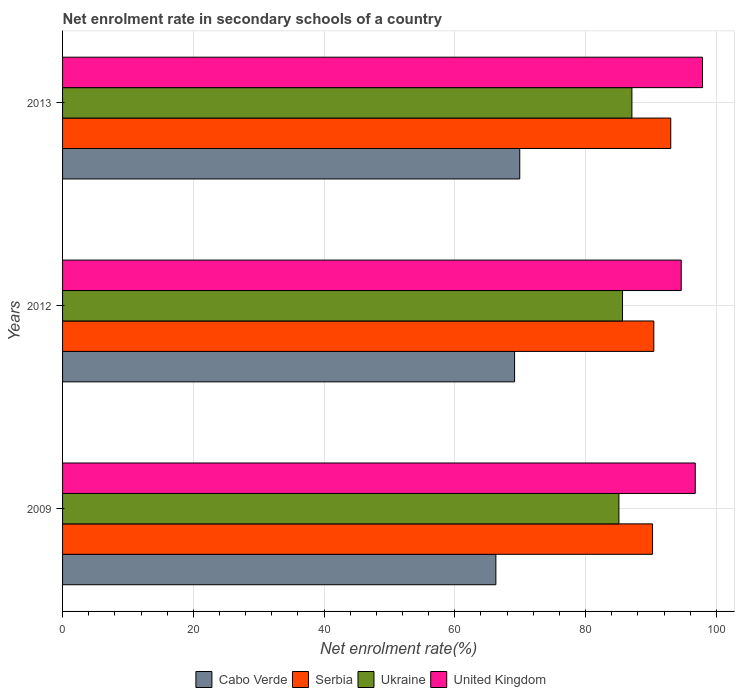How many groups of bars are there?
Your answer should be very brief. 3. What is the net enrolment rate in secondary schools in United Kingdom in 2012?
Provide a short and direct response. 94.63. Across all years, what is the maximum net enrolment rate in secondary schools in Ukraine?
Your answer should be very brief. 87.09. Across all years, what is the minimum net enrolment rate in secondary schools in United Kingdom?
Your answer should be compact. 94.63. In which year was the net enrolment rate in secondary schools in United Kingdom maximum?
Your answer should be very brief. 2013. In which year was the net enrolment rate in secondary schools in Serbia minimum?
Your answer should be very brief. 2009. What is the total net enrolment rate in secondary schools in United Kingdom in the graph?
Give a very brief answer. 289.29. What is the difference between the net enrolment rate in secondary schools in Ukraine in 2009 and that in 2012?
Your answer should be very brief. -0.55. What is the difference between the net enrolment rate in secondary schools in Serbia in 2009 and the net enrolment rate in secondary schools in United Kingdom in 2012?
Keep it short and to the point. -4.39. What is the average net enrolment rate in secondary schools in Cabo Verde per year?
Your answer should be very brief. 68.45. In the year 2009, what is the difference between the net enrolment rate in secondary schools in Serbia and net enrolment rate in secondary schools in United Kingdom?
Make the answer very short. -6.54. What is the ratio of the net enrolment rate in secondary schools in Cabo Verde in 2009 to that in 2012?
Make the answer very short. 0.96. What is the difference between the highest and the second highest net enrolment rate in secondary schools in United Kingdom?
Give a very brief answer. 1.11. What is the difference between the highest and the lowest net enrolment rate in secondary schools in United Kingdom?
Offer a terse response. 3.25. Is it the case that in every year, the sum of the net enrolment rate in secondary schools in Ukraine and net enrolment rate in secondary schools in Cabo Verde is greater than the sum of net enrolment rate in secondary schools in United Kingdom and net enrolment rate in secondary schools in Serbia?
Your answer should be compact. No. What does the 1st bar from the top in 2013 represents?
Offer a very short reply. United Kingdom. What does the 4th bar from the bottom in 2009 represents?
Make the answer very short. United Kingdom. Is it the case that in every year, the sum of the net enrolment rate in secondary schools in United Kingdom and net enrolment rate in secondary schools in Serbia is greater than the net enrolment rate in secondary schools in Cabo Verde?
Offer a terse response. Yes. How many years are there in the graph?
Your answer should be compact. 3. Are the values on the major ticks of X-axis written in scientific E-notation?
Make the answer very short. No. Does the graph contain grids?
Make the answer very short. Yes. Where does the legend appear in the graph?
Offer a terse response. Bottom center. What is the title of the graph?
Your answer should be very brief. Net enrolment rate in secondary schools of a country. Does "Middle East & North Africa (all income levels)" appear as one of the legend labels in the graph?
Ensure brevity in your answer.  No. What is the label or title of the X-axis?
Ensure brevity in your answer.  Net enrolment rate(%). What is the Net enrolment rate(%) of Cabo Verde in 2009?
Your answer should be compact. 66.28. What is the Net enrolment rate(%) of Serbia in 2009?
Your answer should be very brief. 90.24. What is the Net enrolment rate(%) in Ukraine in 2009?
Provide a short and direct response. 85.1. What is the Net enrolment rate(%) of United Kingdom in 2009?
Your answer should be compact. 96.78. What is the Net enrolment rate(%) in Cabo Verde in 2012?
Offer a terse response. 69.14. What is the Net enrolment rate(%) of Serbia in 2012?
Keep it short and to the point. 90.44. What is the Net enrolment rate(%) of Ukraine in 2012?
Provide a short and direct response. 85.65. What is the Net enrolment rate(%) of United Kingdom in 2012?
Give a very brief answer. 94.63. What is the Net enrolment rate(%) in Cabo Verde in 2013?
Give a very brief answer. 69.93. What is the Net enrolment rate(%) in Serbia in 2013?
Your answer should be compact. 93.03. What is the Net enrolment rate(%) of Ukraine in 2013?
Offer a very short reply. 87.09. What is the Net enrolment rate(%) of United Kingdom in 2013?
Make the answer very short. 97.88. Across all years, what is the maximum Net enrolment rate(%) of Cabo Verde?
Offer a terse response. 69.93. Across all years, what is the maximum Net enrolment rate(%) of Serbia?
Give a very brief answer. 93.03. Across all years, what is the maximum Net enrolment rate(%) of Ukraine?
Offer a very short reply. 87.09. Across all years, what is the maximum Net enrolment rate(%) of United Kingdom?
Your response must be concise. 97.88. Across all years, what is the minimum Net enrolment rate(%) in Cabo Verde?
Make the answer very short. 66.28. Across all years, what is the minimum Net enrolment rate(%) of Serbia?
Your response must be concise. 90.24. Across all years, what is the minimum Net enrolment rate(%) of Ukraine?
Offer a terse response. 85.1. Across all years, what is the minimum Net enrolment rate(%) in United Kingdom?
Your response must be concise. 94.63. What is the total Net enrolment rate(%) of Cabo Verde in the graph?
Ensure brevity in your answer.  205.35. What is the total Net enrolment rate(%) of Serbia in the graph?
Make the answer very short. 273.71. What is the total Net enrolment rate(%) of Ukraine in the graph?
Offer a very short reply. 257.84. What is the total Net enrolment rate(%) of United Kingdom in the graph?
Give a very brief answer. 289.29. What is the difference between the Net enrolment rate(%) in Cabo Verde in 2009 and that in 2012?
Your answer should be very brief. -2.86. What is the difference between the Net enrolment rate(%) of Serbia in 2009 and that in 2012?
Provide a succinct answer. -0.2. What is the difference between the Net enrolment rate(%) in Ukraine in 2009 and that in 2012?
Make the answer very short. -0.55. What is the difference between the Net enrolment rate(%) in United Kingdom in 2009 and that in 2012?
Offer a very short reply. 2.14. What is the difference between the Net enrolment rate(%) in Cabo Verde in 2009 and that in 2013?
Your answer should be very brief. -3.65. What is the difference between the Net enrolment rate(%) of Serbia in 2009 and that in 2013?
Provide a succinct answer. -2.79. What is the difference between the Net enrolment rate(%) of Ukraine in 2009 and that in 2013?
Offer a terse response. -1.99. What is the difference between the Net enrolment rate(%) of United Kingdom in 2009 and that in 2013?
Make the answer very short. -1.11. What is the difference between the Net enrolment rate(%) of Cabo Verde in 2012 and that in 2013?
Your response must be concise. -0.79. What is the difference between the Net enrolment rate(%) in Serbia in 2012 and that in 2013?
Your answer should be very brief. -2.59. What is the difference between the Net enrolment rate(%) in Ukraine in 2012 and that in 2013?
Keep it short and to the point. -1.44. What is the difference between the Net enrolment rate(%) in United Kingdom in 2012 and that in 2013?
Make the answer very short. -3.25. What is the difference between the Net enrolment rate(%) in Cabo Verde in 2009 and the Net enrolment rate(%) in Serbia in 2012?
Offer a very short reply. -24.16. What is the difference between the Net enrolment rate(%) in Cabo Verde in 2009 and the Net enrolment rate(%) in Ukraine in 2012?
Offer a very short reply. -19.37. What is the difference between the Net enrolment rate(%) in Cabo Verde in 2009 and the Net enrolment rate(%) in United Kingdom in 2012?
Provide a short and direct response. -28.35. What is the difference between the Net enrolment rate(%) of Serbia in 2009 and the Net enrolment rate(%) of Ukraine in 2012?
Provide a succinct answer. 4.59. What is the difference between the Net enrolment rate(%) of Serbia in 2009 and the Net enrolment rate(%) of United Kingdom in 2012?
Ensure brevity in your answer.  -4.39. What is the difference between the Net enrolment rate(%) of Ukraine in 2009 and the Net enrolment rate(%) of United Kingdom in 2012?
Your response must be concise. -9.53. What is the difference between the Net enrolment rate(%) of Cabo Verde in 2009 and the Net enrolment rate(%) of Serbia in 2013?
Ensure brevity in your answer.  -26.75. What is the difference between the Net enrolment rate(%) in Cabo Verde in 2009 and the Net enrolment rate(%) in Ukraine in 2013?
Give a very brief answer. -20.81. What is the difference between the Net enrolment rate(%) of Cabo Verde in 2009 and the Net enrolment rate(%) of United Kingdom in 2013?
Your answer should be very brief. -31.61. What is the difference between the Net enrolment rate(%) in Serbia in 2009 and the Net enrolment rate(%) in Ukraine in 2013?
Offer a very short reply. 3.15. What is the difference between the Net enrolment rate(%) in Serbia in 2009 and the Net enrolment rate(%) in United Kingdom in 2013?
Offer a terse response. -7.64. What is the difference between the Net enrolment rate(%) in Ukraine in 2009 and the Net enrolment rate(%) in United Kingdom in 2013?
Your answer should be compact. -12.78. What is the difference between the Net enrolment rate(%) of Cabo Verde in 2012 and the Net enrolment rate(%) of Serbia in 2013?
Provide a succinct answer. -23.89. What is the difference between the Net enrolment rate(%) in Cabo Verde in 2012 and the Net enrolment rate(%) in Ukraine in 2013?
Ensure brevity in your answer.  -17.95. What is the difference between the Net enrolment rate(%) of Cabo Verde in 2012 and the Net enrolment rate(%) of United Kingdom in 2013?
Provide a short and direct response. -28.74. What is the difference between the Net enrolment rate(%) of Serbia in 2012 and the Net enrolment rate(%) of Ukraine in 2013?
Make the answer very short. 3.35. What is the difference between the Net enrolment rate(%) in Serbia in 2012 and the Net enrolment rate(%) in United Kingdom in 2013?
Give a very brief answer. -7.45. What is the difference between the Net enrolment rate(%) of Ukraine in 2012 and the Net enrolment rate(%) of United Kingdom in 2013?
Your response must be concise. -12.23. What is the average Net enrolment rate(%) in Cabo Verde per year?
Make the answer very short. 68.45. What is the average Net enrolment rate(%) in Serbia per year?
Offer a terse response. 91.24. What is the average Net enrolment rate(%) of Ukraine per year?
Give a very brief answer. 85.95. What is the average Net enrolment rate(%) of United Kingdom per year?
Keep it short and to the point. 96.43. In the year 2009, what is the difference between the Net enrolment rate(%) of Cabo Verde and Net enrolment rate(%) of Serbia?
Ensure brevity in your answer.  -23.96. In the year 2009, what is the difference between the Net enrolment rate(%) in Cabo Verde and Net enrolment rate(%) in Ukraine?
Give a very brief answer. -18.82. In the year 2009, what is the difference between the Net enrolment rate(%) of Cabo Verde and Net enrolment rate(%) of United Kingdom?
Your answer should be compact. -30.5. In the year 2009, what is the difference between the Net enrolment rate(%) of Serbia and Net enrolment rate(%) of Ukraine?
Provide a short and direct response. 5.14. In the year 2009, what is the difference between the Net enrolment rate(%) in Serbia and Net enrolment rate(%) in United Kingdom?
Ensure brevity in your answer.  -6.54. In the year 2009, what is the difference between the Net enrolment rate(%) in Ukraine and Net enrolment rate(%) in United Kingdom?
Your response must be concise. -11.68. In the year 2012, what is the difference between the Net enrolment rate(%) of Cabo Verde and Net enrolment rate(%) of Serbia?
Keep it short and to the point. -21.3. In the year 2012, what is the difference between the Net enrolment rate(%) of Cabo Verde and Net enrolment rate(%) of Ukraine?
Provide a short and direct response. -16.51. In the year 2012, what is the difference between the Net enrolment rate(%) in Cabo Verde and Net enrolment rate(%) in United Kingdom?
Your answer should be very brief. -25.49. In the year 2012, what is the difference between the Net enrolment rate(%) of Serbia and Net enrolment rate(%) of Ukraine?
Your answer should be compact. 4.79. In the year 2012, what is the difference between the Net enrolment rate(%) of Serbia and Net enrolment rate(%) of United Kingdom?
Offer a terse response. -4.19. In the year 2012, what is the difference between the Net enrolment rate(%) of Ukraine and Net enrolment rate(%) of United Kingdom?
Give a very brief answer. -8.98. In the year 2013, what is the difference between the Net enrolment rate(%) in Cabo Verde and Net enrolment rate(%) in Serbia?
Ensure brevity in your answer.  -23.1. In the year 2013, what is the difference between the Net enrolment rate(%) in Cabo Verde and Net enrolment rate(%) in Ukraine?
Offer a terse response. -17.16. In the year 2013, what is the difference between the Net enrolment rate(%) in Cabo Verde and Net enrolment rate(%) in United Kingdom?
Provide a succinct answer. -27.95. In the year 2013, what is the difference between the Net enrolment rate(%) of Serbia and Net enrolment rate(%) of Ukraine?
Keep it short and to the point. 5.94. In the year 2013, what is the difference between the Net enrolment rate(%) in Serbia and Net enrolment rate(%) in United Kingdom?
Give a very brief answer. -4.86. In the year 2013, what is the difference between the Net enrolment rate(%) in Ukraine and Net enrolment rate(%) in United Kingdom?
Offer a very short reply. -10.8. What is the ratio of the Net enrolment rate(%) of Cabo Verde in 2009 to that in 2012?
Ensure brevity in your answer.  0.96. What is the ratio of the Net enrolment rate(%) of United Kingdom in 2009 to that in 2012?
Offer a very short reply. 1.02. What is the ratio of the Net enrolment rate(%) of Cabo Verde in 2009 to that in 2013?
Your answer should be very brief. 0.95. What is the ratio of the Net enrolment rate(%) of Ukraine in 2009 to that in 2013?
Your response must be concise. 0.98. What is the ratio of the Net enrolment rate(%) of United Kingdom in 2009 to that in 2013?
Offer a very short reply. 0.99. What is the ratio of the Net enrolment rate(%) of Cabo Verde in 2012 to that in 2013?
Make the answer very short. 0.99. What is the ratio of the Net enrolment rate(%) in Serbia in 2012 to that in 2013?
Provide a succinct answer. 0.97. What is the ratio of the Net enrolment rate(%) in Ukraine in 2012 to that in 2013?
Keep it short and to the point. 0.98. What is the ratio of the Net enrolment rate(%) in United Kingdom in 2012 to that in 2013?
Keep it short and to the point. 0.97. What is the difference between the highest and the second highest Net enrolment rate(%) in Cabo Verde?
Your answer should be compact. 0.79. What is the difference between the highest and the second highest Net enrolment rate(%) of Serbia?
Make the answer very short. 2.59. What is the difference between the highest and the second highest Net enrolment rate(%) in Ukraine?
Provide a short and direct response. 1.44. What is the difference between the highest and the second highest Net enrolment rate(%) in United Kingdom?
Keep it short and to the point. 1.11. What is the difference between the highest and the lowest Net enrolment rate(%) in Cabo Verde?
Give a very brief answer. 3.65. What is the difference between the highest and the lowest Net enrolment rate(%) in Serbia?
Ensure brevity in your answer.  2.79. What is the difference between the highest and the lowest Net enrolment rate(%) in Ukraine?
Your response must be concise. 1.99. What is the difference between the highest and the lowest Net enrolment rate(%) of United Kingdom?
Keep it short and to the point. 3.25. 